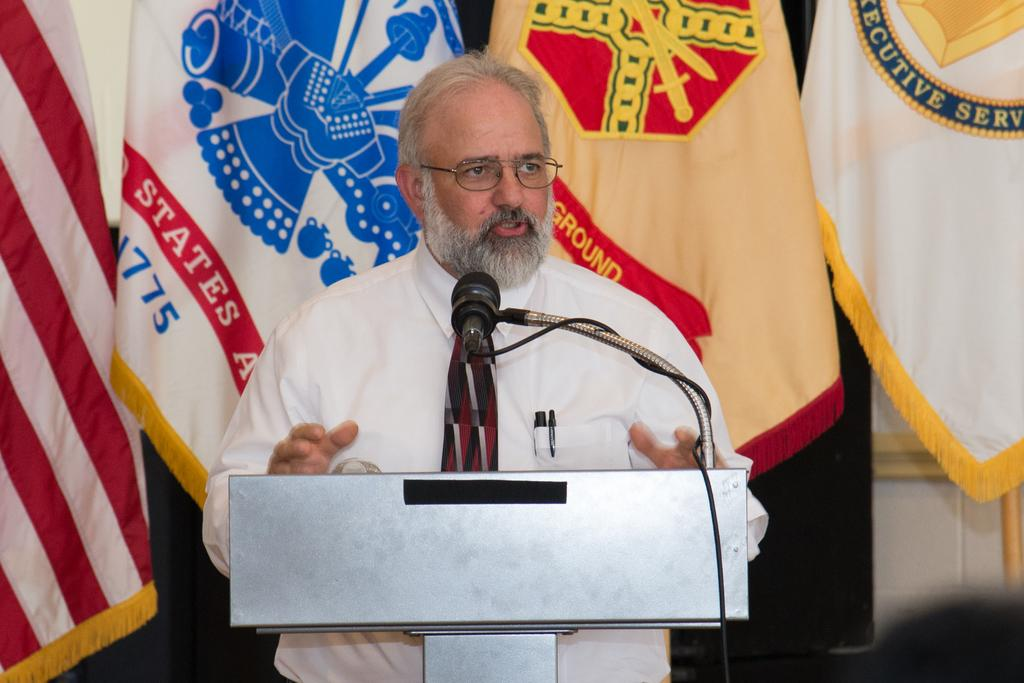<image>
Provide a brief description of the given image. A man at a podium in front of a flag with States and 1775 on it 